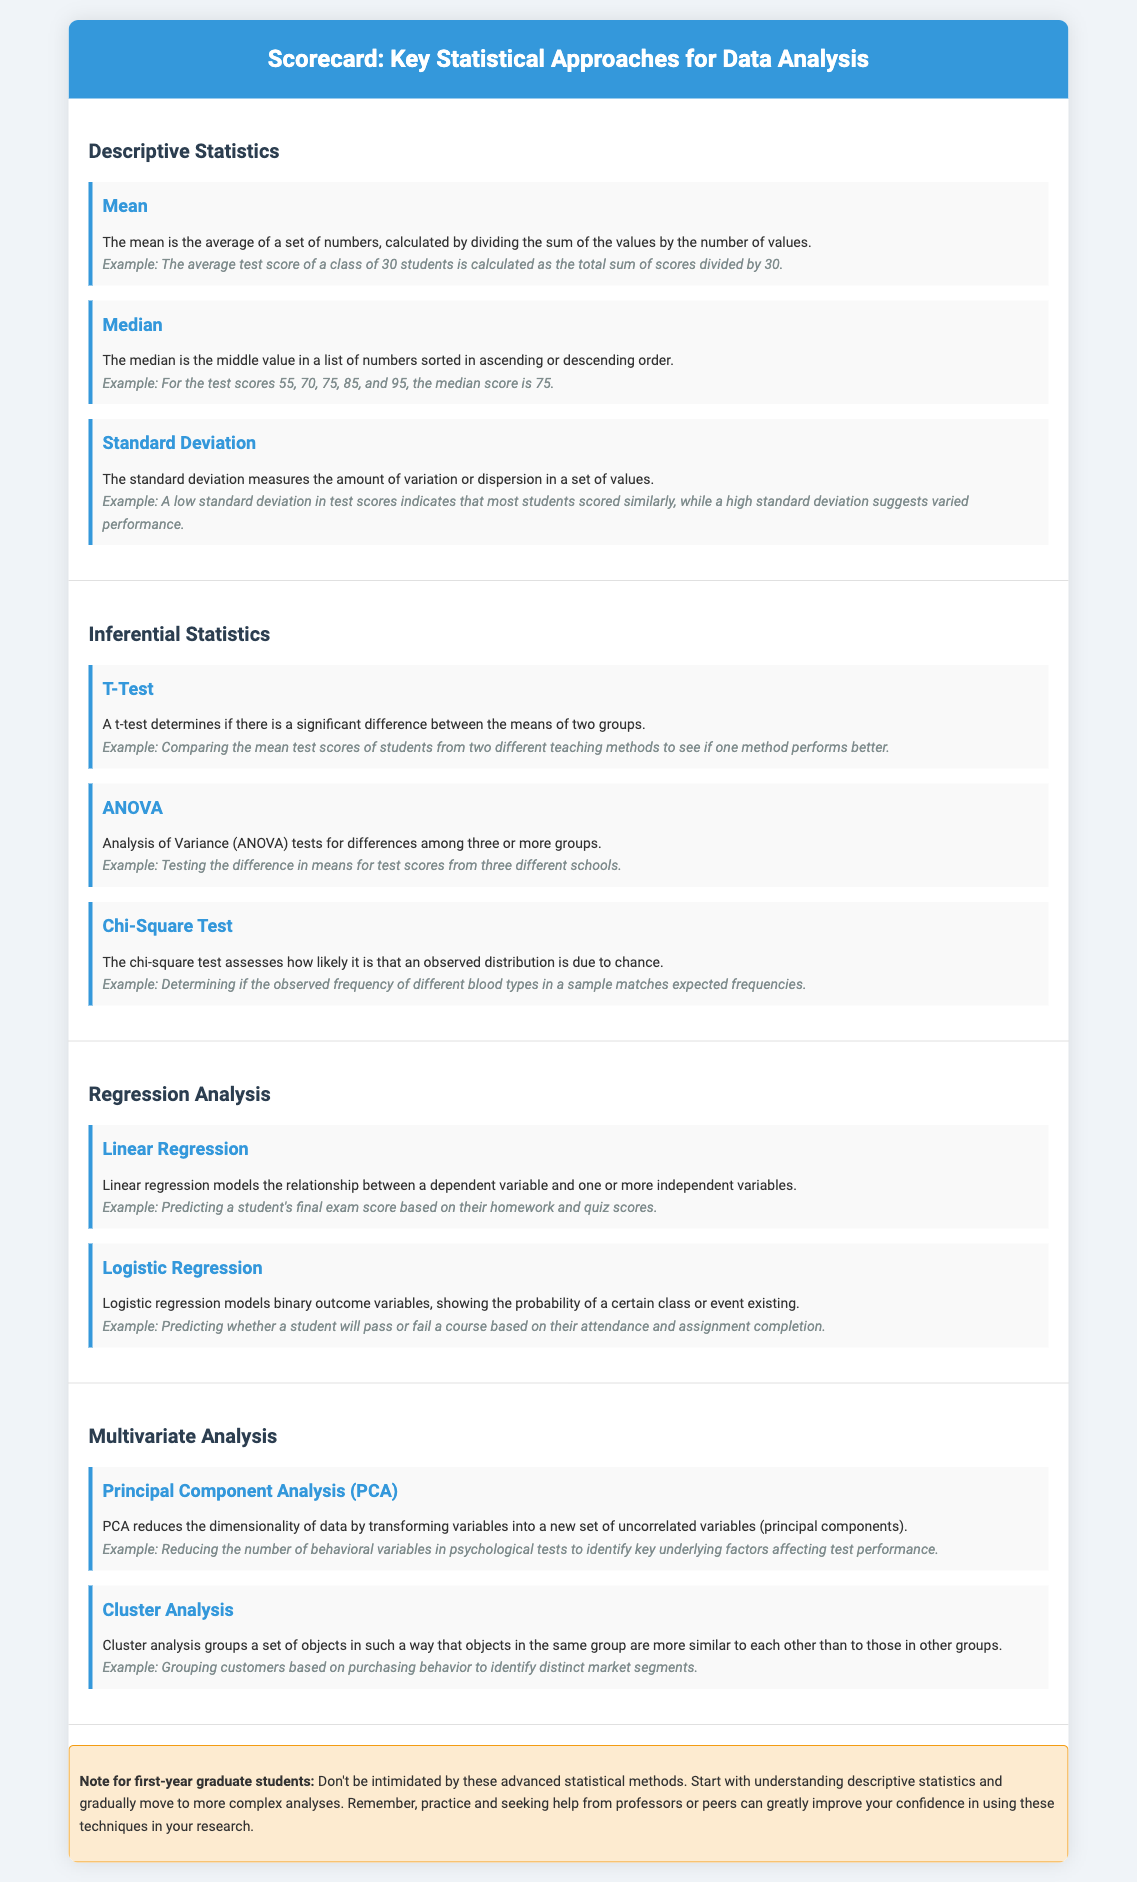What is the first statistical approach listed? The first statistical approach in the document is Descriptive Statistics.
Answer: Descriptive Statistics What does the Chi-Square Test assess? The Chi-Square Test assesses how likely it is that an observed distribution is due to chance.
Answer: Due to chance What example is given for Linear Regression? The example for Linear Regression is predicting a student's final exam score based on their homework and quiz scores.
Answer: Predicting a student's final exam score How many content items are there under Inferential Statistics? There are three content items listed under Inferential Statistics: T-Test, ANOVA, and Chi-Square Test.
Answer: Three What is the purpose of Principal Component Analysis (PCA)? The purpose of PCA is to reduce the dimensionality of data by transforming variables into uncorrelated variables.
Answer: Reduce dimensionality What example is provided for Cluster Analysis? The example provided for Cluster Analysis is grouping customers based on purchasing behavior.
Answer: Grouping customers based on purchasing behavior What does the note for first-year graduate students emphasize? The note emphasizes that first-year graduate students should not be intimidated by advanced statistical methods and should start with descriptive statistics.
Answer: Not be intimidated What is the relationship between Logistic Regression and binary outcome variables? Logistic Regression models binary outcome variables, showing the probability of a certain class or event existing.
Answer: Models binary outcome variables 